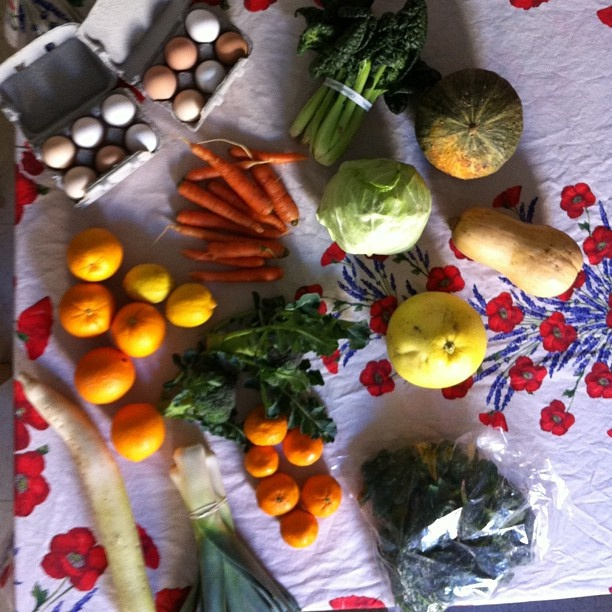Describe the objects in this image and their specific colors. I can see dining table in black, maroon, gray, lavender, and darkgray tones, broccoli in black, gray, and white tones, broccoli in black, darkgreen, and gray tones, orange in black, orange, maroon, and gold tones, and orange in black, maroon, orange, red, and gold tones in this image. 